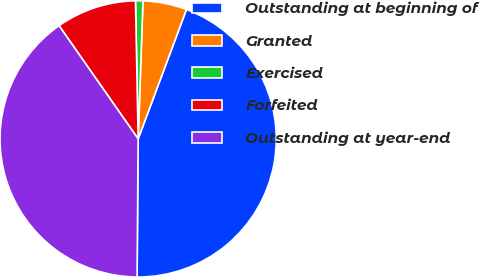<chart> <loc_0><loc_0><loc_500><loc_500><pie_chart><fcel>Outstanding at beginning of<fcel>Granted<fcel>Exercised<fcel>Forfeited<fcel>Outstanding at year-end<nl><fcel>44.43%<fcel>5.13%<fcel>0.86%<fcel>9.4%<fcel>40.16%<nl></chart> 